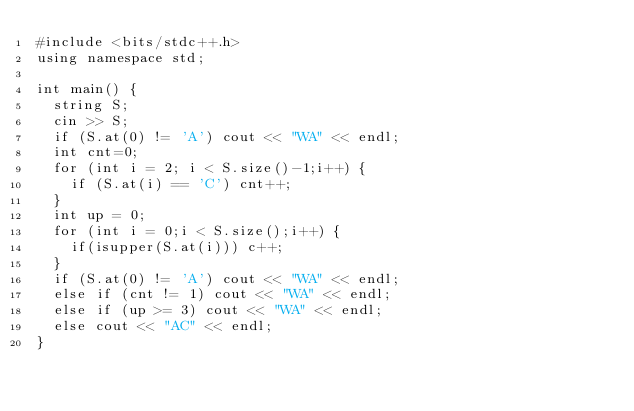Convert code to text. <code><loc_0><loc_0><loc_500><loc_500><_C++_>#include <bits/stdc++.h>
using namespace std;

int main() {
  string S;
  cin >> S;
  if (S.at(0) != 'A') cout << "WA" << endl;
  int cnt=0;
  for (int i = 2; i < S.size()-1;i++) {
    if (S.at(i) == 'C') cnt++;
  }
  int up = 0;
  for (int i = 0;i < S.size();i++) {
    if(isupper(S.at(i))) c++;
  }
  if (S.at(0) != 'A') cout << "WA" << endl;
  else if (cnt != 1) cout << "WA" << endl;
  else if (up >= 3) cout << "WA" << endl;
  else cout << "AC" << endl;
}
 
 
  
  </code> 